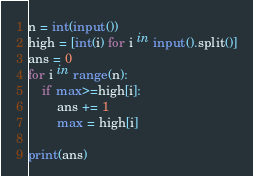<code> <loc_0><loc_0><loc_500><loc_500><_Python_>n = int(input())
high = [int(i) for i in input().split()]
ans = 0
for i in range(n):
    if max>=high[i]:
        ans += 1
        max = high[i]

print(ans)</code> 